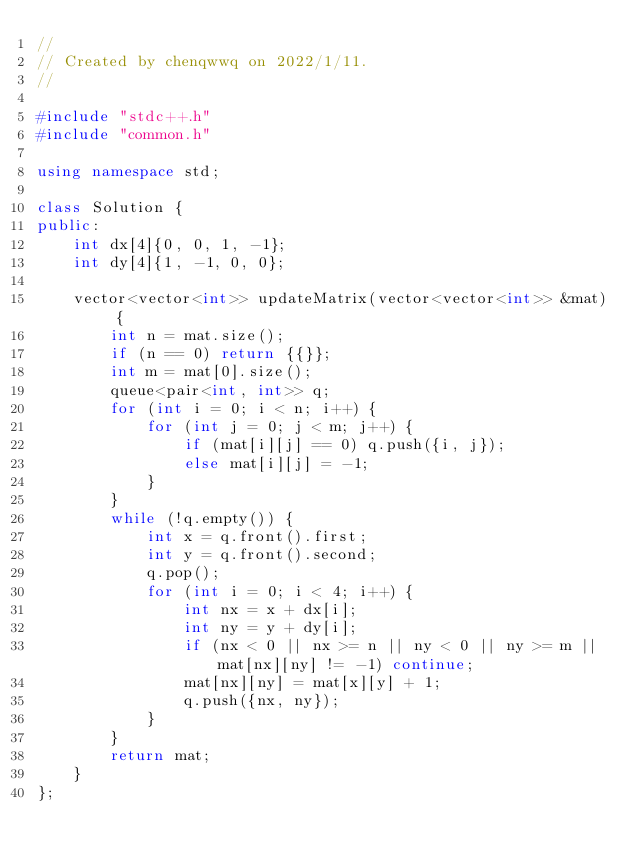<code> <loc_0><loc_0><loc_500><loc_500><_C++_>//
// Created by chenqwwq on 2022/1/11.
//

#include "stdc++.h"
#include "common.h"

using namespace std;

class Solution {
public:
    int dx[4]{0, 0, 1, -1};
    int dy[4]{1, -1, 0, 0};

    vector<vector<int>> updateMatrix(vector<vector<int>> &mat) {
        int n = mat.size();
        if (n == 0) return {{}};
        int m = mat[0].size();
        queue<pair<int, int>> q;
        for (int i = 0; i < n; i++) {
            for (int j = 0; j < m; j++) {
                if (mat[i][j] == 0) q.push({i, j});
                else mat[i][j] = -1;
            }
        }
        while (!q.empty()) {
            int x = q.front().first;
            int y = q.front().second;
            q.pop();
            for (int i = 0; i < 4; i++) {
                int nx = x + dx[i];
                int ny = y + dy[i];
                if (nx < 0 || nx >= n || ny < 0 || ny >= m || mat[nx][ny] != -1) continue;
                mat[nx][ny] = mat[x][y] + 1;
                q.push({nx, ny});
            }
        }
        return mat;
    }
};</code> 